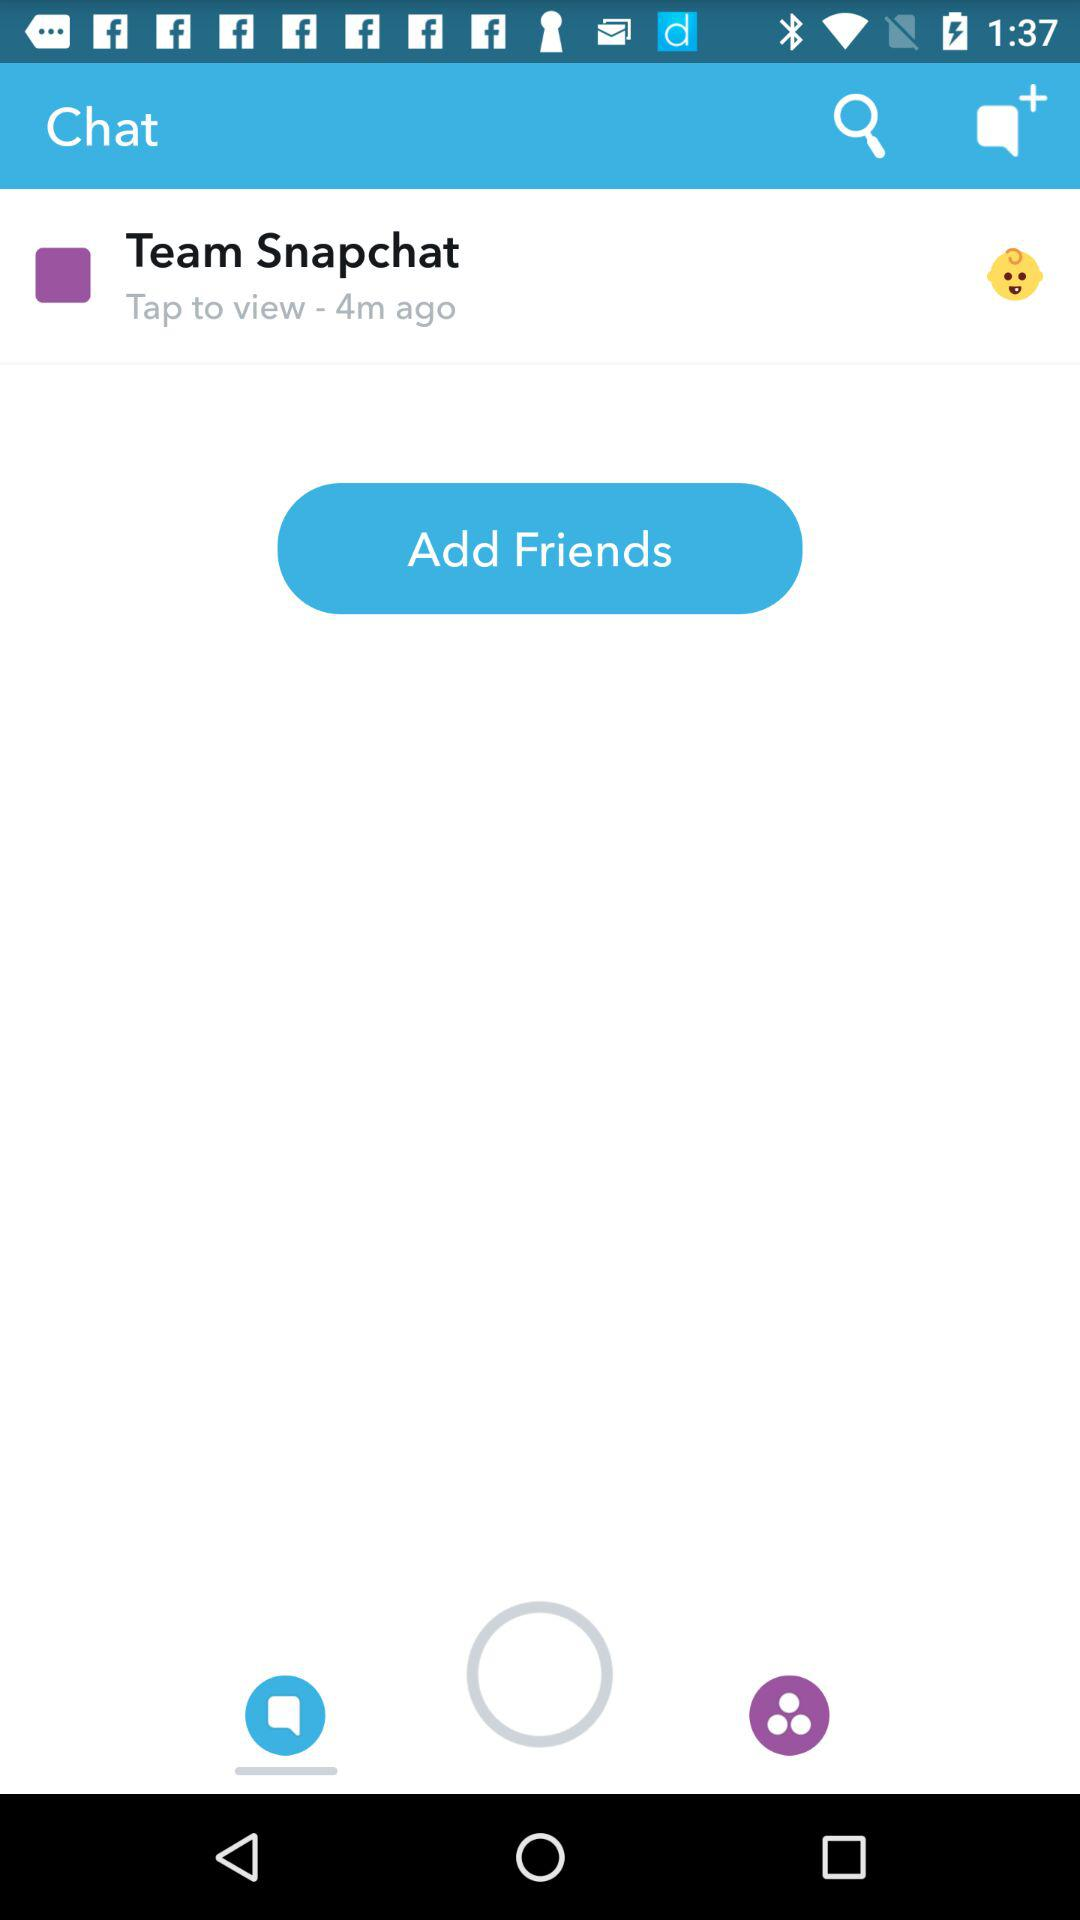How long ago did Team Snapchat message? Team Snapchat sent a message 4 minutes ago. 